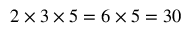Convert formula to latex. <formula><loc_0><loc_0><loc_500><loc_500>2 \times 3 \times 5 = 6 \times 5 = 3 0</formula> 